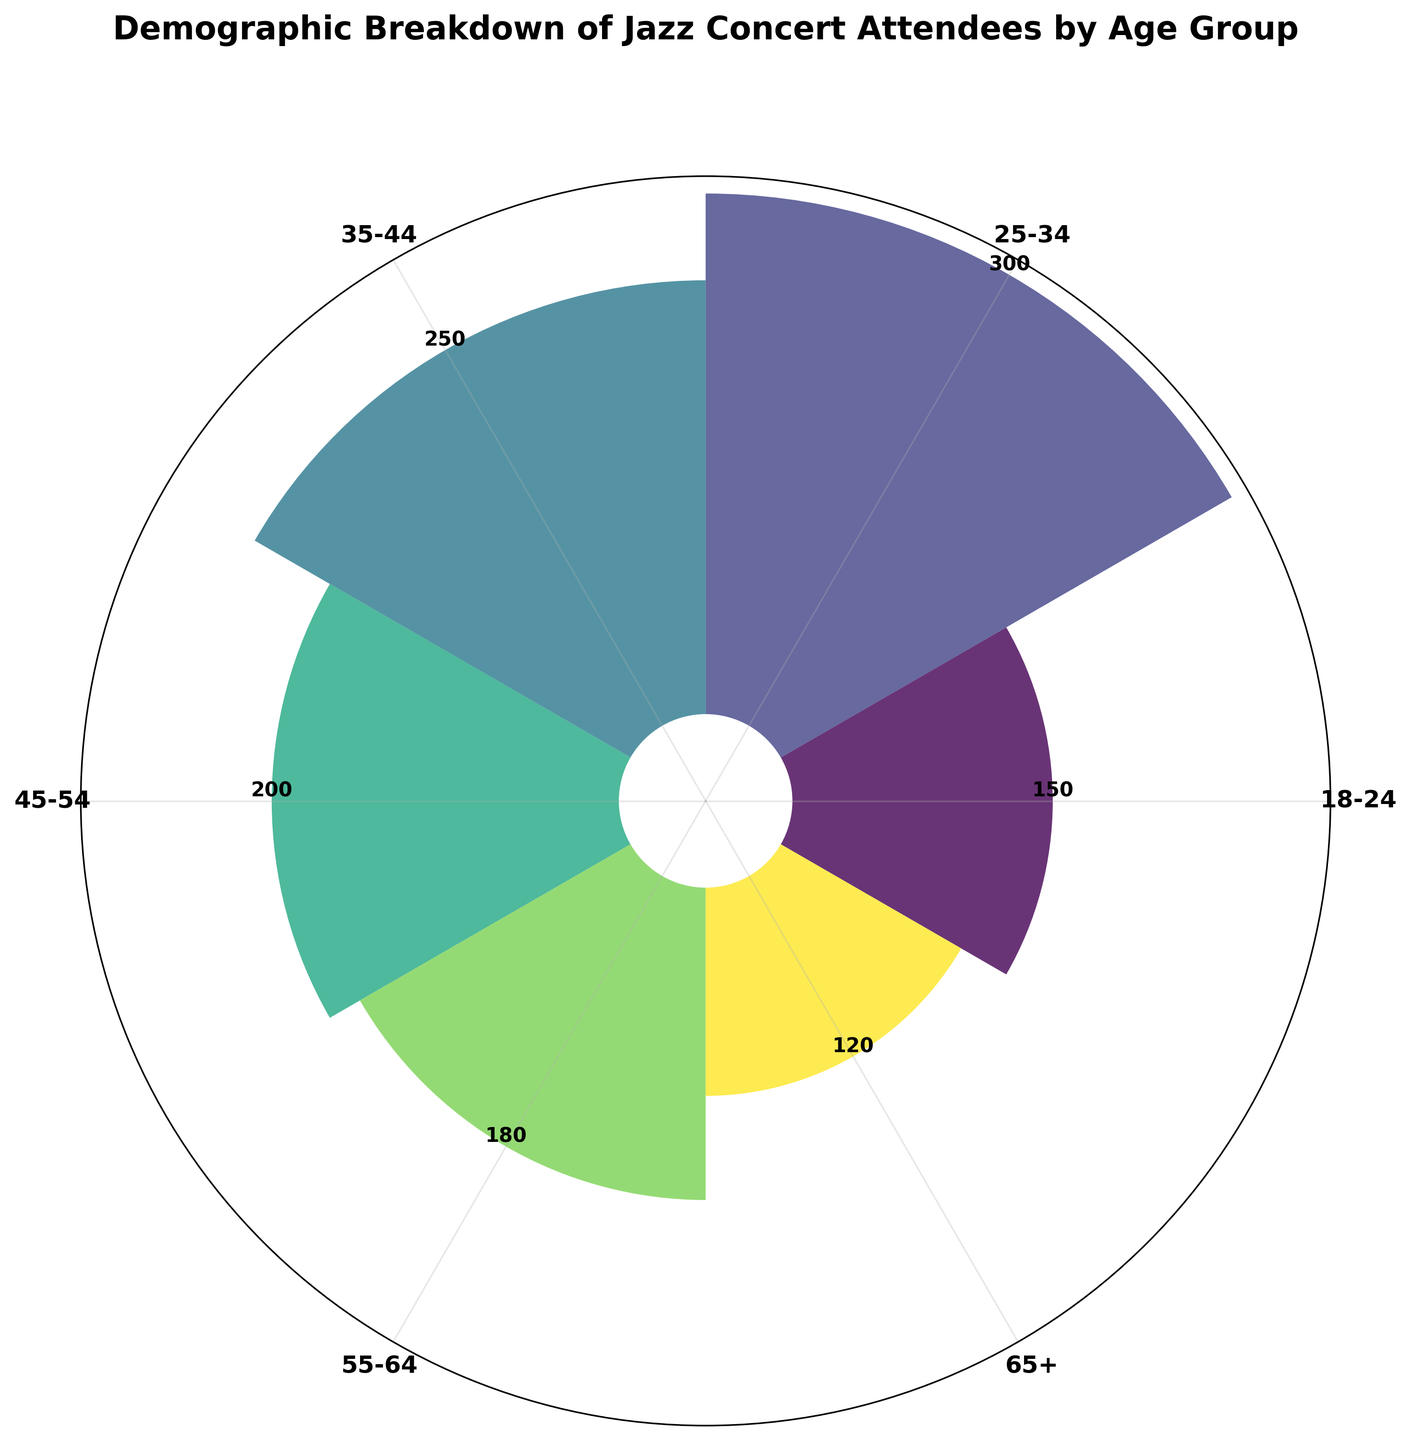What is the title of the figure? The title of the figure is usually located at the top. Here, the text at the top of the chart reads "Demographic Breakdown of Jazz Concert Attendees by Age Group."
Answer: Demographic Breakdown of Jazz Concert Attendees by Age Group Which age group has the highest number of attendees? By examining the lengths of the bars, the age group with the highest number of attendees has the longest bar. Here, the "25-34" age group's bar is the longest.
Answer: 25-34 What is the total number of attendees from all age groups combined? To find the total, sum the counts of all age groups. 150 (18-24) + 300 (25-34) + 250 (35-44) + 200 (45-54) + 180 (55-64) + 120 (65+). 150 + 300 + 250 + 200 + 180 + 120 = 1200.
Answer: 1200 How many more attendees are in the 25-34 age group compared to the 65+ age group? Subtract the number of attendees in the 65+ age group from the number in the 25-34 age group. 300 (25-34) - 120 (65+). 300 - 120 = 180.
Answer: 180 Which two adjacent age groups combined have the largest number of attendees? Look for two adjacent bars on the rose chart that have the largest combined height. The 25-34 and 35-44 segments combined are the largest. 300 (25-34) + 250 (35-44). 300 + 250 = 550.
Answer: 25-34 and 35-44 What is the average number of attendees per age group? Divide the total number of attendees by the number of age groups. There are 6 age groups. Total attendees is 1200. 1200 / 6 = 200.
Answer: 200 Which age groups have fewer than 200 attendees? Identify bars that are shorter than the 200 attendee mark. The 18-24 (150), 65+ (120), and 55-64 (180) groups all have fewer than 200 attendees.
Answer: 18-24, 55-64, 65+ What is the count shown on the bar for the 45-54 age group? Observe the labeled count next to the height of the bar corresponding to the 45-54 age group. It shows 200.
Answer: 200 Is the number of attendees in the 35-44 age group more or less than the total of the 18-24 and 65+ groups? Compare the 35-44 count with the sum of the 18-24 and 65+ counts. 35-44 has 250; 18-24 and 65+ combined is 150 + 120 = 270. 250 is less than 270.
Answer: Less 